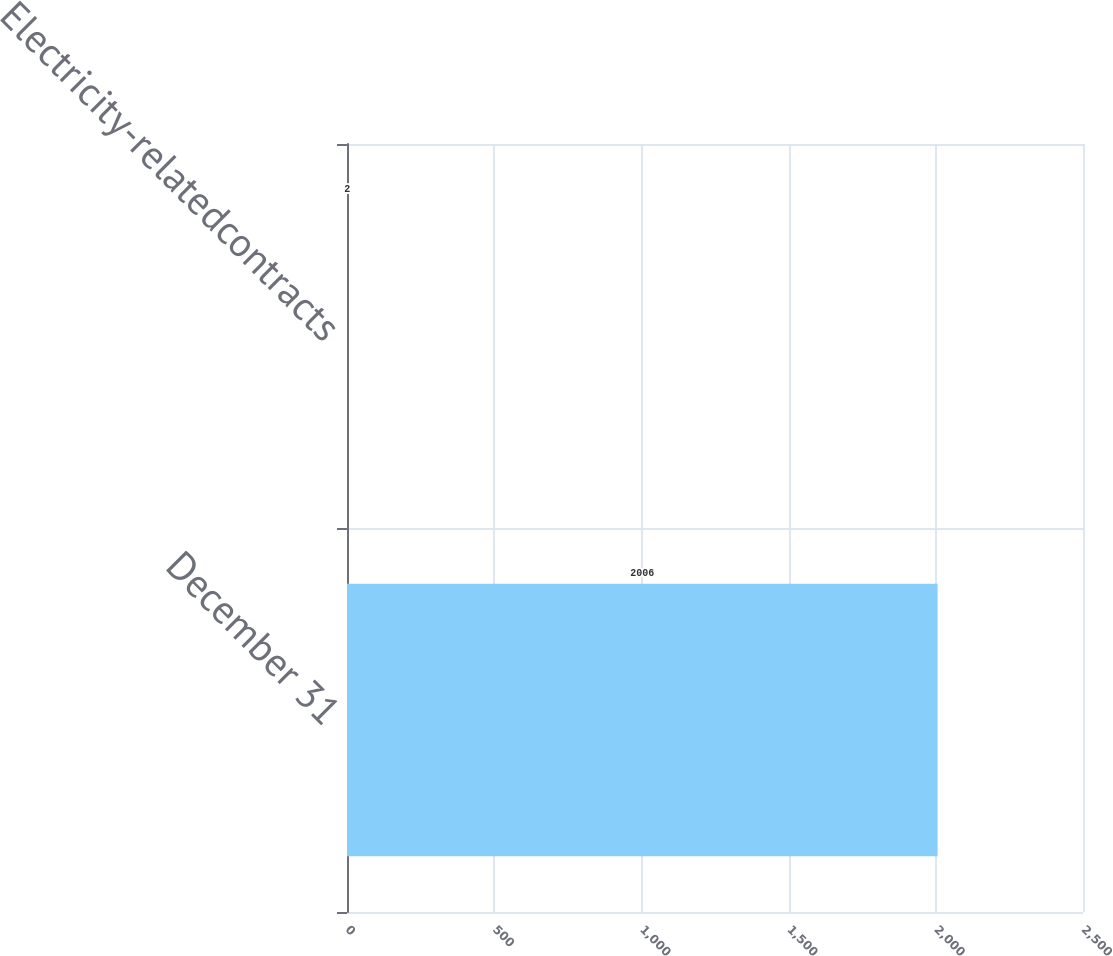Convert chart to OTSL. <chart><loc_0><loc_0><loc_500><loc_500><bar_chart><fcel>December 31<fcel>Electricity-relatedcontracts<nl><fcel>2006<fcel>2<nl></chart> 